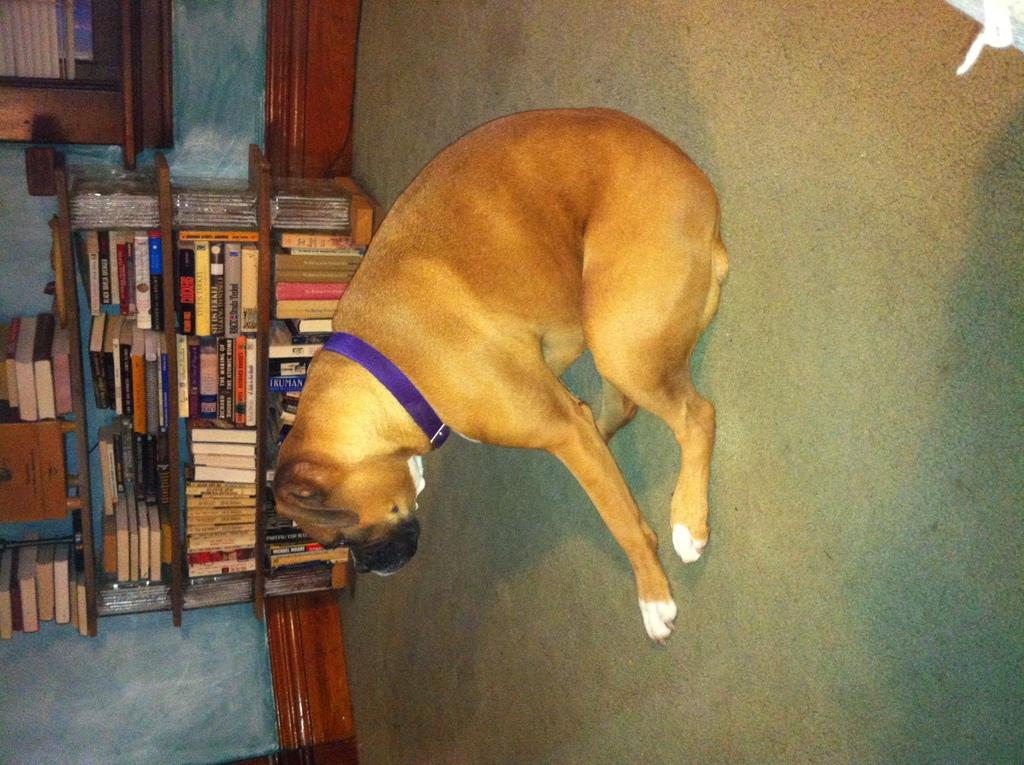What is the main subject in the foreground of the image? There is a dog in the foreground of the image. What is the dog doing in the image? The dog is sitting on the ground. What can be seen in the background of the image? There are books on a shelf, a wall, a window with window blinds, and a surface visible in the background of the image. What type of lip can be seen on the dog in the image? There are no lips visible on the dog in the image, as dogs do not have lips like humans. What muscle is the dog using to hold the part of the book in the image? There is no book visible in the dog's possession in the image, and therefore no muscle or part of a book can be identified. 